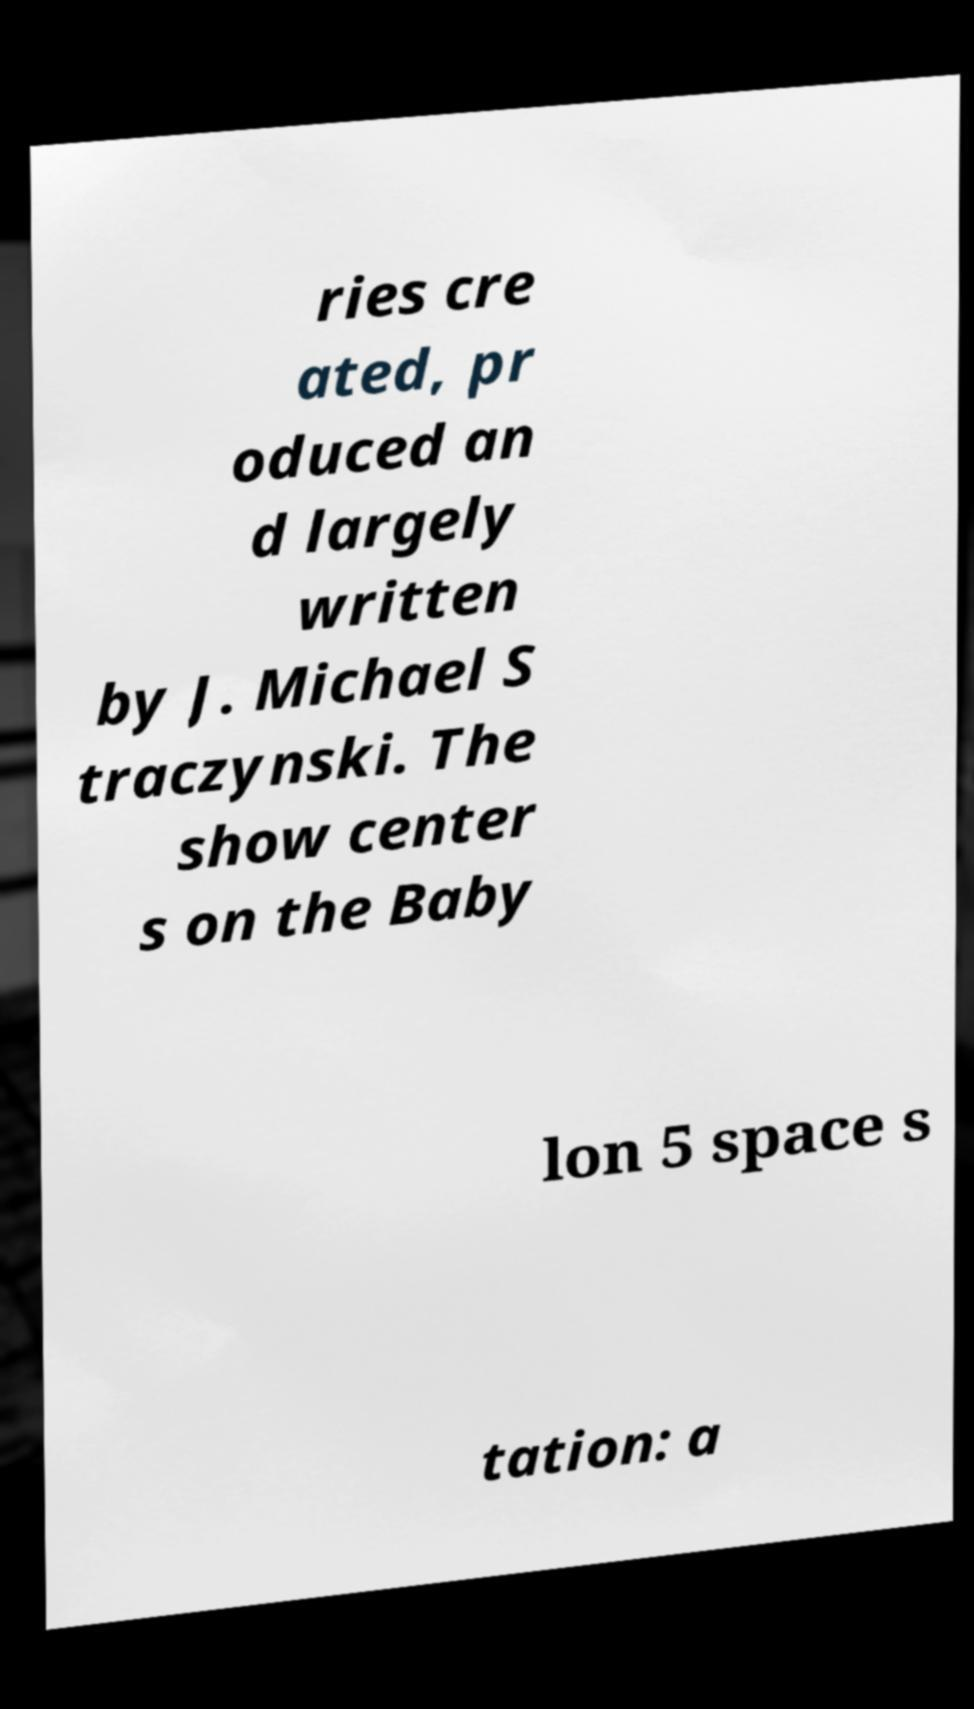Could you assist in decoding the text presented in this image and type it out clearly? ries cre ated, pr oduced an d largely written by J. Michael S traczynski. The show center s on the Baby lon 5 space s tation: a 